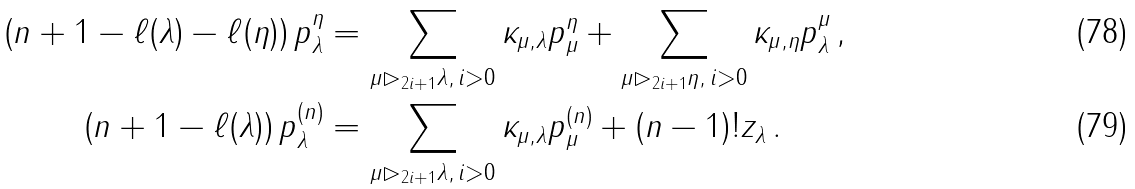Convert formula to latex. <formula><loc_0><loc_0><loc_500><loc_500>\left ( n + 1 - \ell ( \lambda ) - \ell ( \eta ) \right ) p ^ { \eta } _ { \lambda } & = \sum _ { \mu \rhd _ { 2 i + 1 } \lambda , \, i > 0 } \kappa _ { \mu , \lambda } p ^ { \eta } _ { \mu } + \sum _ { \mu \rhd _ { 2 i + 1 } \eta , \, i > 0 } \kappa _ { \mu , \eta } p ^ { \mu } _ { \lambda } \, , \\ \left ( n + 1 - \ell ( \lambda ) \right ) p ^ { ( n ) } _ { \lambda } & = \sum _ { \mu \rhd _ { 2 i + 1 } \lambda , \, i > 0 } \kappa _ { \mu , \lambda } p ^ { ( n ) } _ { \mu } + ( n - 1 ) ! z _ { \lambda } \, .</formula> 